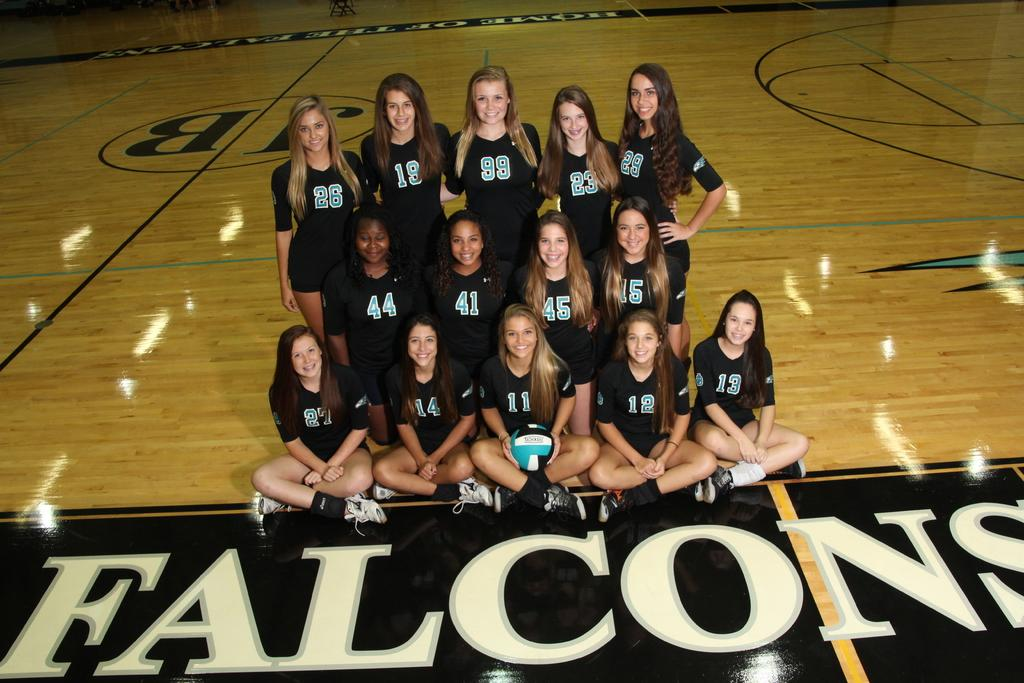What is the main subject of the image? The main subject of the image is a group of people. What are the people in the image doing? The people are standing and smiling. What are the people wearing in the image? The people are wearing black jerseys. What can be seen on the jerseys? The jerseys have numbers printed on them. What type of authority figure can be seen in the image? There is no authority figure present in the image; it features a group of people wearing black jerseys with numbers. How many wings are visible on the people in the image? There are no wings visible on the people in the image; they are wearing black jerseys with numbers. 